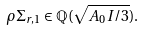Convert formula to latex. <formula><loc_0><loc_0><loc_500><loc_500>\rho \Sigma _ { r , 1 } \in \mathbb { Q } ( \sqrt { A _ { 0 } I / 3 } ) .</formula> 